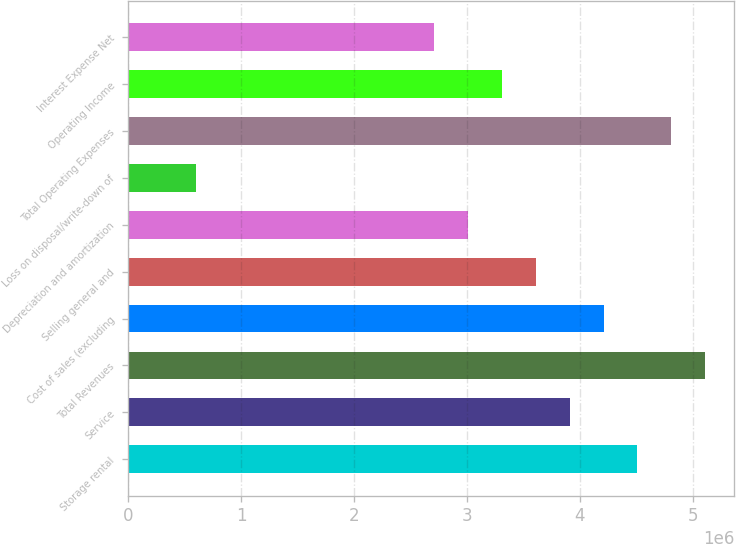Convert chart. <chart><loc_0><loc_0><loc_500><loc_500><bar_chart><fcel>Storage rental<fcel>Service<fcel>Total Revenues<fcel>Cost of sales (excluding<fcel>Selling general and<fcel>Depreciation and amortization<fcel>Loss on disposal/write-down of<fcel>Total Operating Expenses<fcel>Operating Income<fcel>Interest Expense Net<nl><fcel>4.51154e+06<fcel>3.91011e+06<fcel>5.11296e+06<fcel>4.21083e+06<fcel>3.6094e+06<fcel>3.00798e+06<fcel>602275<fcel>4.81225e+06<fcel>3.30869e+06<fcel>2.70726e+06<nl></chart> 